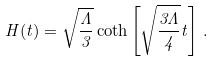Convert formula to latex. <formula><loc_0><loc_0><loc_500><loc_500>H ( t ) = \sqrt { \frac { \Lambda } { 3 } } \coth \left [ \sqrt { \frac { 3 \Lambda } { 4 } } t \right ] \, .</formula> 